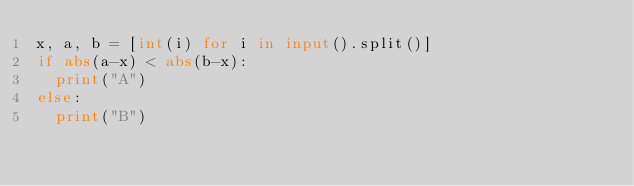Convert code to text. <code><loc_0><loc_0><loc_500><loc_500><_Python_>x, a, b = [int(i) for i in input().split()]
if abs(a-x) < abs(b-x):
  print("A")
else:
  print("B")</code> 